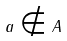<formula> <loc_0><loc_0><loc_500><loc_500>a \notin A</formula> 